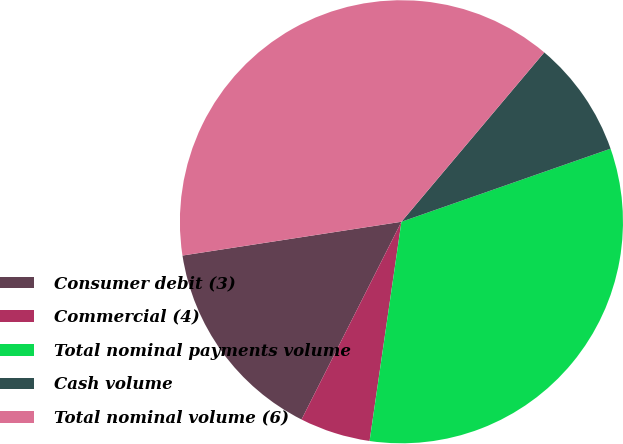Convert chart to OTSL. <chart><loc_0><loc_0><loc_500><loc_500><pie_chart><fcel>Consumer debit (3)<fcel>Commercial (4)<fcel>Total nominal payments volume<fcel>Cash volume<fcel>Total nominal volume (6)<nl><fcel>15.12%<fcel>5.15%<fcel>32.65%<fcel>8.5%<fcel>38.59%<nl></chart> 